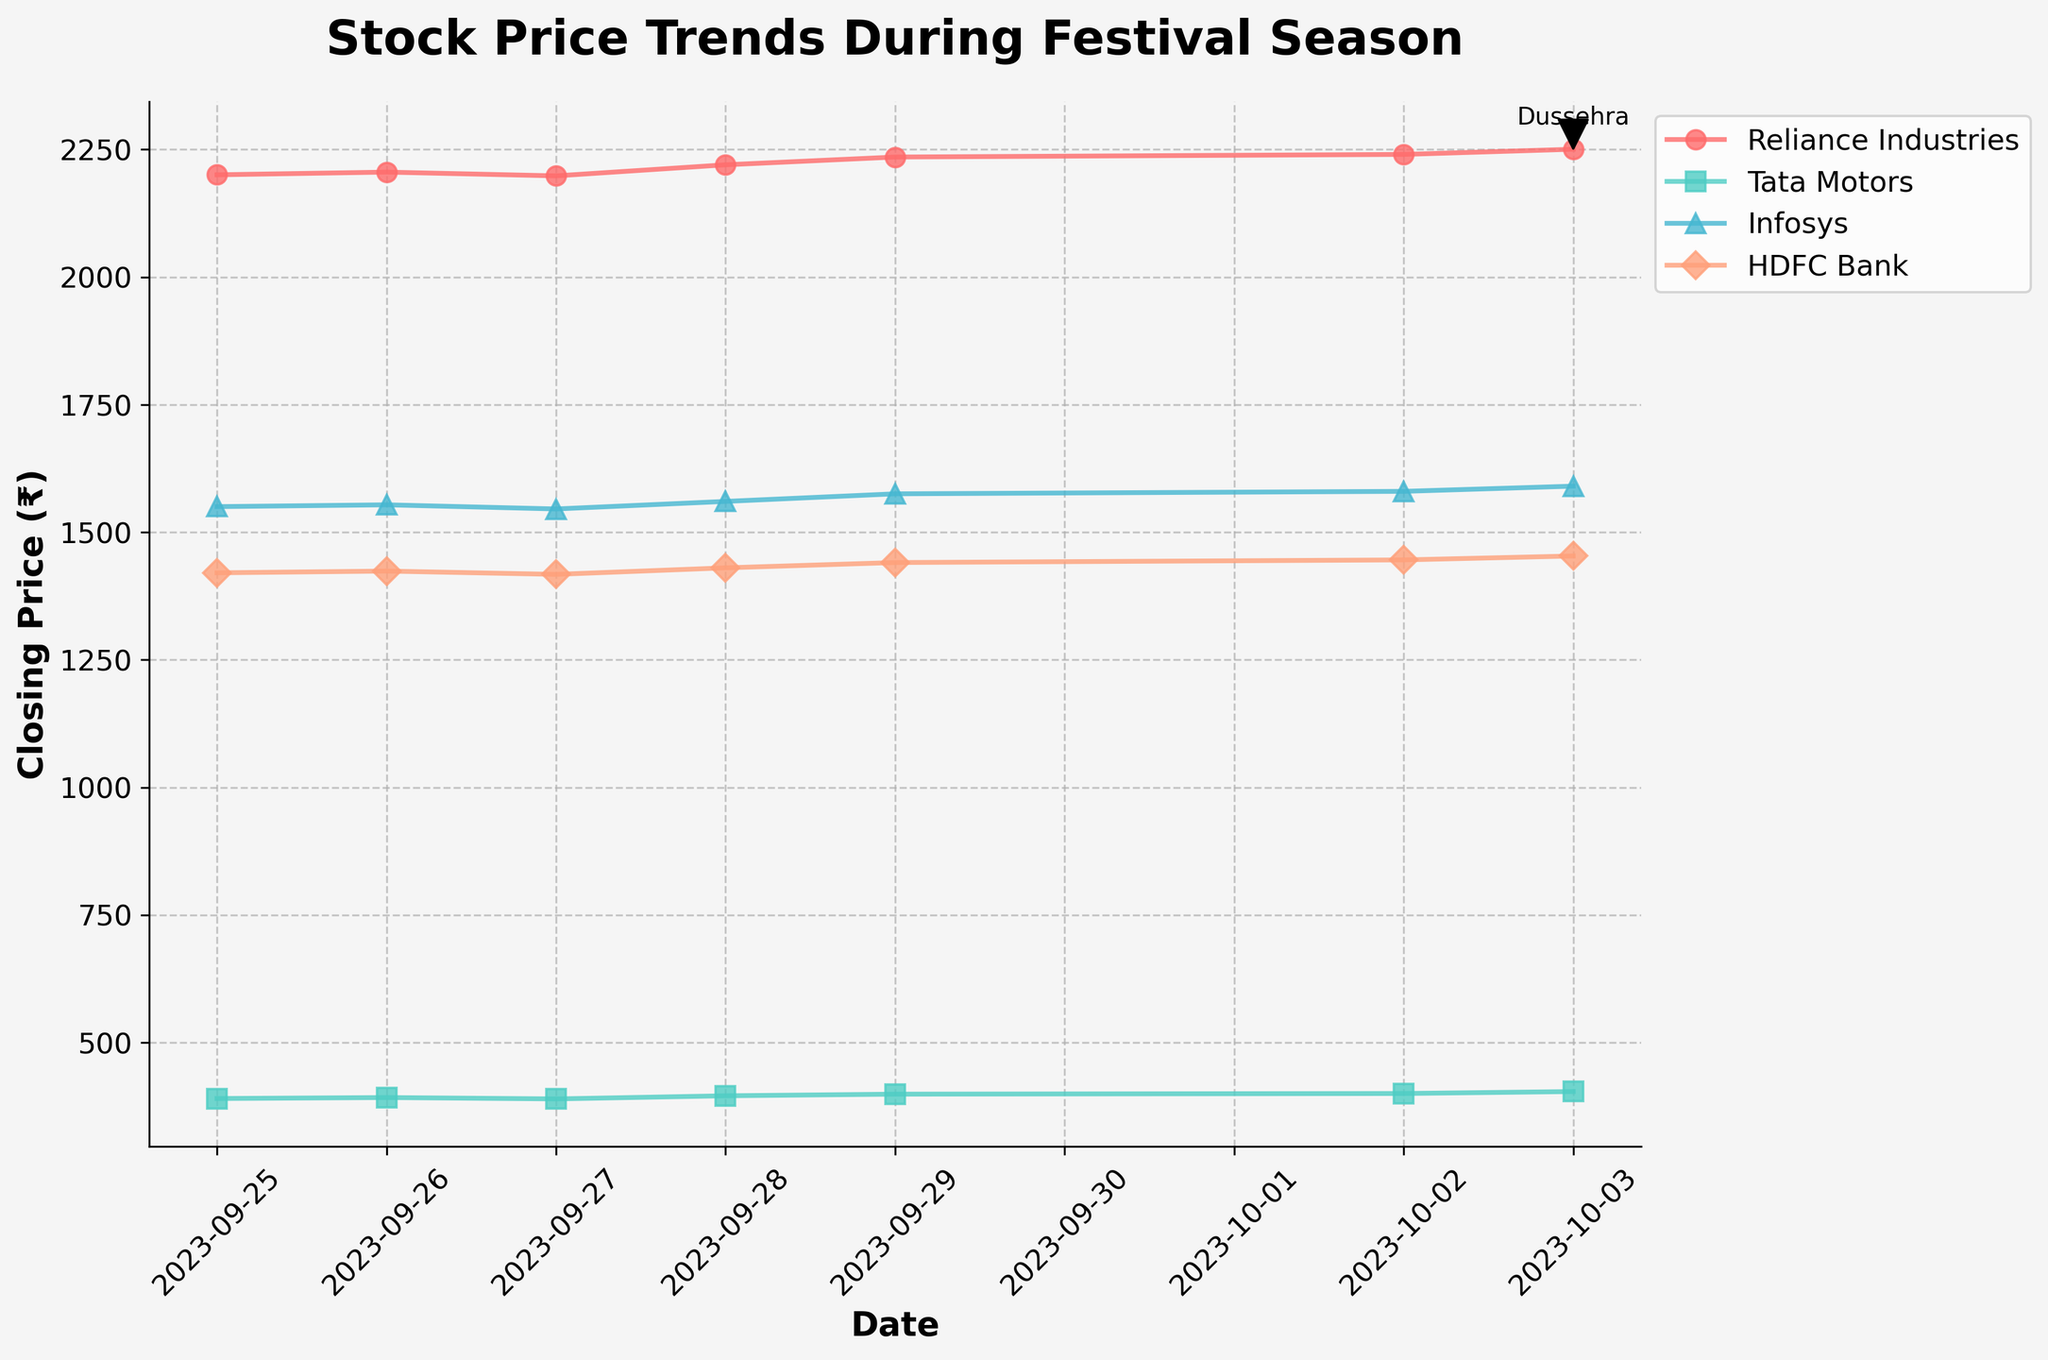What is the title of the plot? The title of the plot is located at the top and provides an overview of what the plot represents.
Answer: Stock Price Trends During Festival Season Which stock had the highest closing price on October 3, 2023? Look at the closing prices on October 3, 2023, for each stock and identify the highest value.
Answer: Reliance Industries What pattern can you observe in the stock prices of Tata Motors from September 25 to October 3, 2023? Examine the closing prices of Tata Motors across the specified dates and describe the trend noticed.
Answer: Increasing trend Between Reliance Industries and Infosys, which stock had a higher closing price on September 29, 2023? Compare the closing prices of these two stocks on the given date and identify the higher one.
Answer: Reliance Industries How did the volume of trades for HDFC Bank change from September 25 to October 3, 2023? Check the volume of trades for each date within the given range and describe the trend.
Answer: Increasing trend What is the difference in the closing price of Reliance Industries between September 25 and October 3, 2023? Subtract the closing price on September 25 from the closing price on October 3 for Reliance Industries.
Answer: 50.10 On which date did Infosys have its lowest closing price within the given period? Look through each date for Infosys and identify the date with the lowest closing price.
Answer: September 27, 2023 Which stock shows an upward spike closest to Dussehra (October 3, 2023)? Observe the trends and identify which stock shows a noticeable upward spike around October 3, 2023.
Answer: Infosys How does the stock price trend for Tata Motors compare to the other stocks in the same period? Analyze the trends for Tata Motors and compare them to the trends of the other stocks across the given dates.
Answer: Consistent upward trend similar to Infosys and Reliance Industries, but at a lower price point Between September 25 and October 3, 2023, which stock's closing price consistently increased without falling? Examine each stock's closing prices and identify the stock whose prices kept increasing without any drop.
Answer: Tatat Motors 